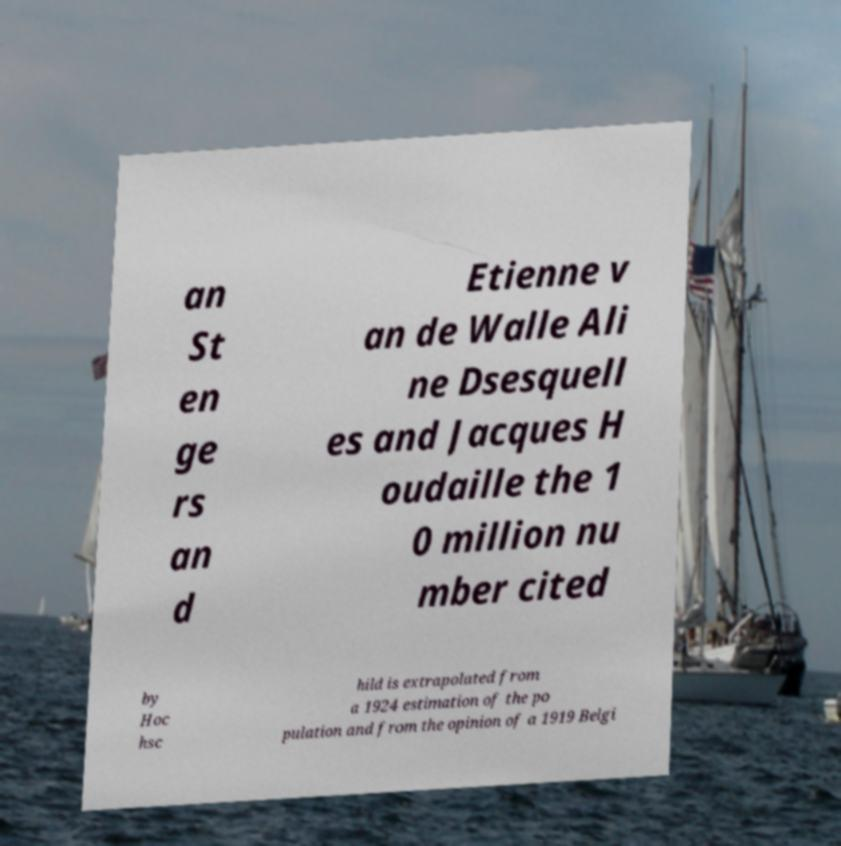What messages or text are displayed in this image? I need them in a readable, typed format. an St en ge rs an d Etienne v an de Walle Ali ne Dsesquell es and Jacques H oudaille the 1 0 million nu mber cited by Hoc hsc hild is extrapolated from a 1924 estimation of the po pulation and from the opinion of a 1919 Belgi 